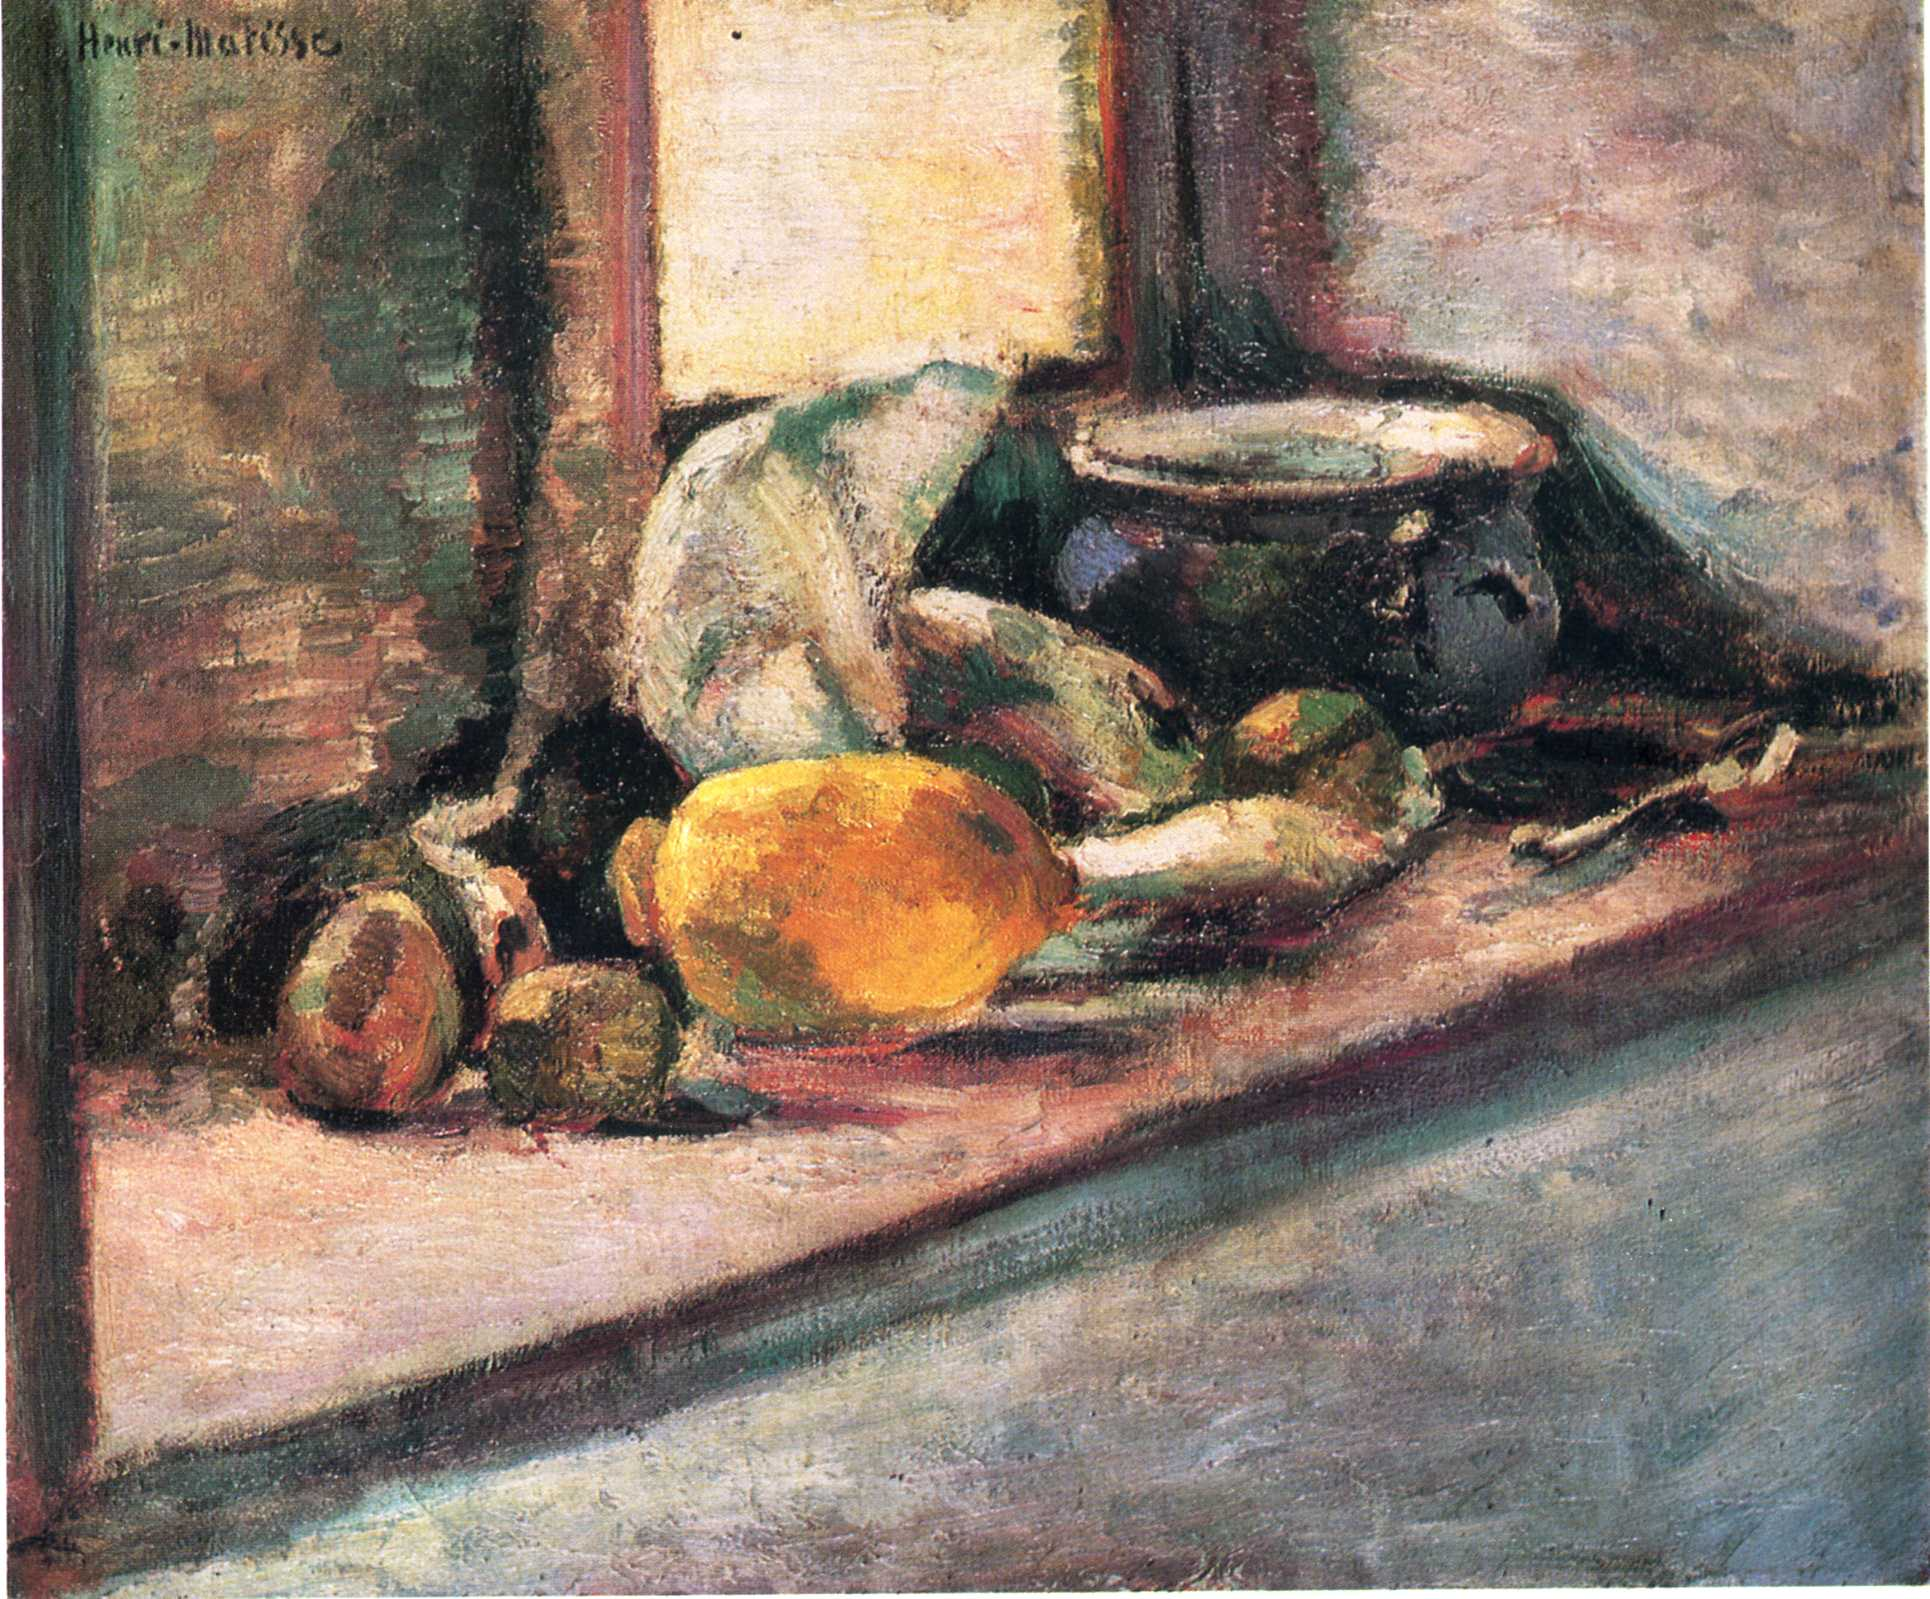What does the placement of objects in this Matisse painting suggest about the artist’s intention? The deliberate arrangement of the objects in the painting may suggest Matisse's intention to focus on harmony and balance. By strategically placing these items, he draws the viewer's eye across the painting, creating a sense of movement and interplay. The seemingly casual scatter of fruits and contrasting colors could be reflecting his fascination with depicting light and shadow as well as his exploration of depth, enticing viewers to look deeper into the everyday simplicity. 